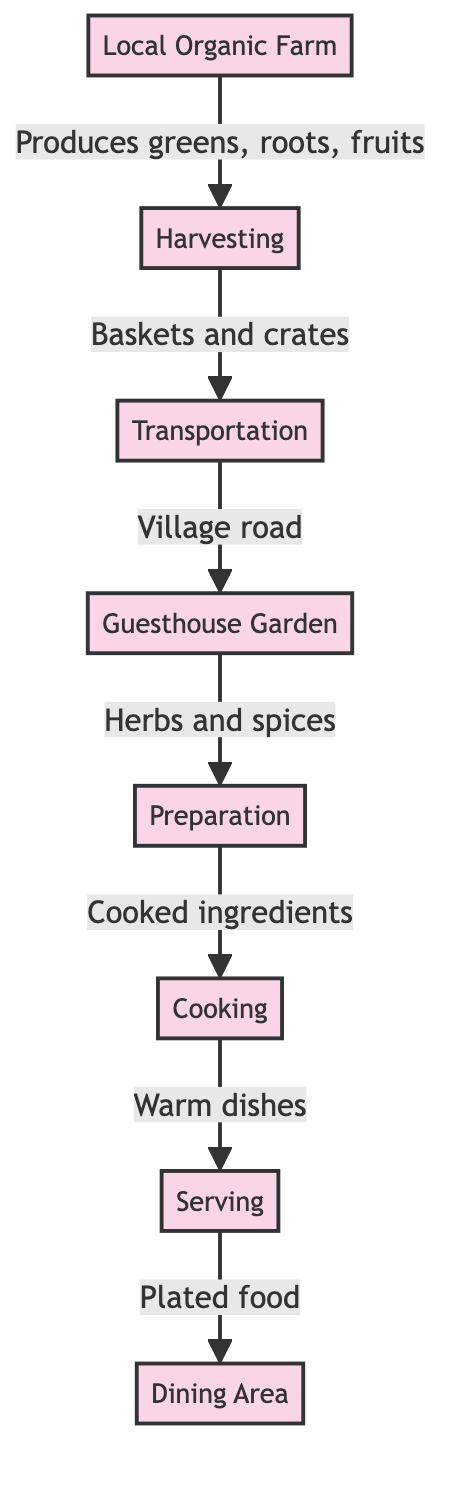What is the first step in the farm-to-table process? The first step in the process is represented by the node labeled "Local Organic Farm," which indicates where the ingredients are produced initially.
Answer: Local Organic Farm How many nodes are present in the diagram? Counting all distinct locations through which the process flows reveals there are 8 nodes: Local Organic Farm, Harvesting, Transportation, Guesthouse Garden, Preparation, Cooking, Serving, and Dining Area.
Answer: 8 Which node is responsible for cooking the ingredients? The "Cooking" node is explicitly indicated as the step where the ingredients are prepared into warm dishes.
Answer: Cooking What type of transportation connects harvesting to the guesthouse? The diagram describes the transportation as occurring along the "Village road," which is the connecting route from harvesting to the guesthouse.
Answer: Village road What is served to the guests in the dining area? The "Plated food" node indicates that the final output served to guests is represented by this label, showing they are served plated dishes.
Answer: Plated food What do the guesthouse garden provide for preparation? The guesthouse garden provides "Herbs and spices," which are essential for the dish preparation process before cooking occurs.
Answer: Herbs and spices Which step follows after transportation? The next step following transportation is represented by the node labeled "Guesthouse Garden," where the goods are received after being transported.
Answer: Guesthouse Garden What is the relationship between preparation and cooking? The relationship illustrated in the diagram shows that "Cooked ingredients" are the output from the "Preparation" node, leading into "Cooking."
Answer: Cooked ingredients Which node is situated right before the dining area? The "Serving" node is positioned directly before "Dining Area," indicating that food is served to guests from this step.
Answer: Serving 